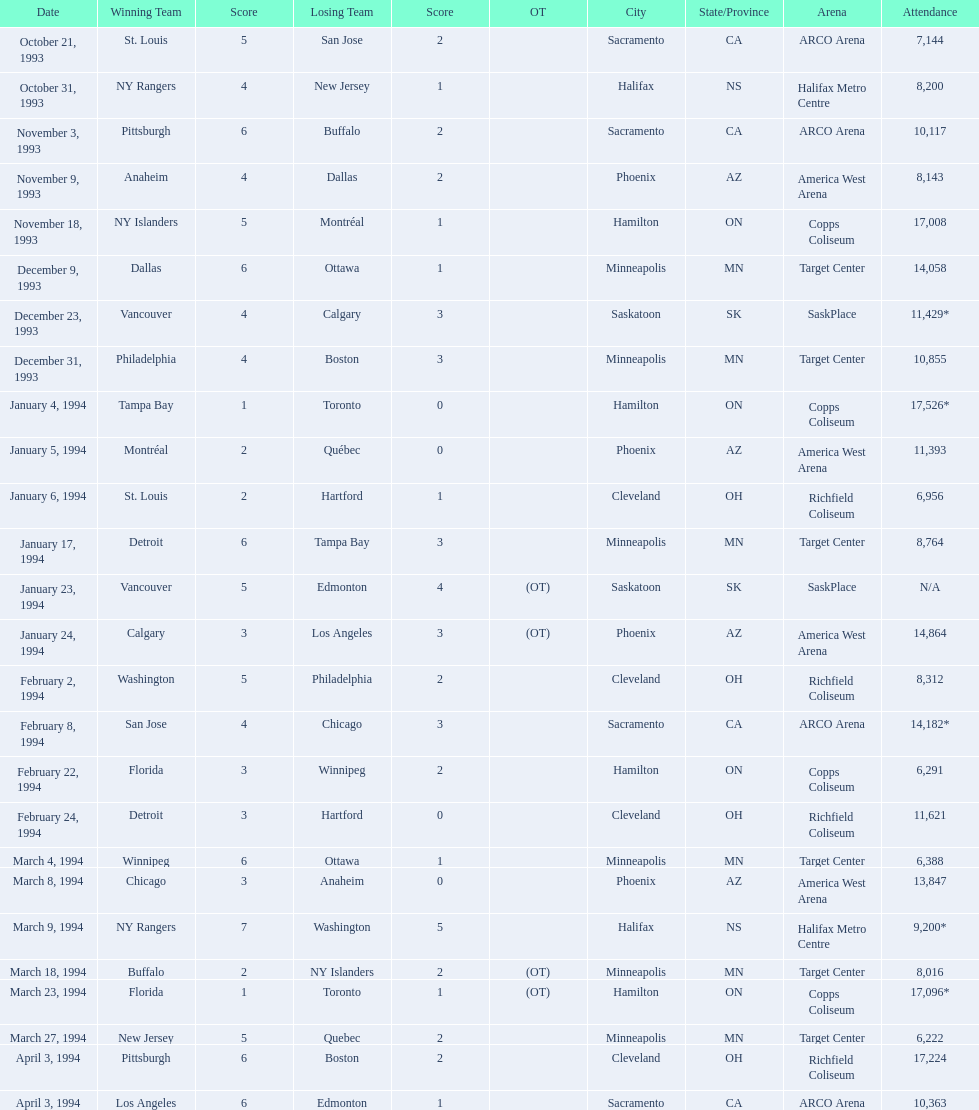Can you provide the attendance data for the 1993-94 nhl season? 7,144, 8,200, 10,117, 8,143, 17,008, 14,058, 11,429*, 10,855, 17,526*, 11,393, 6,956, 8,764, N/A, 14,864, 8,312, 14,182*, 6,291, 11,621, 6,388, 13,847, 9,200*, 8,016, 17,096*, 6,222, 17,224, 10,363. Which game recorded the highest number of attendees? 17,526*. What was the date of this game with the highest attendance? January 4, 1994. 